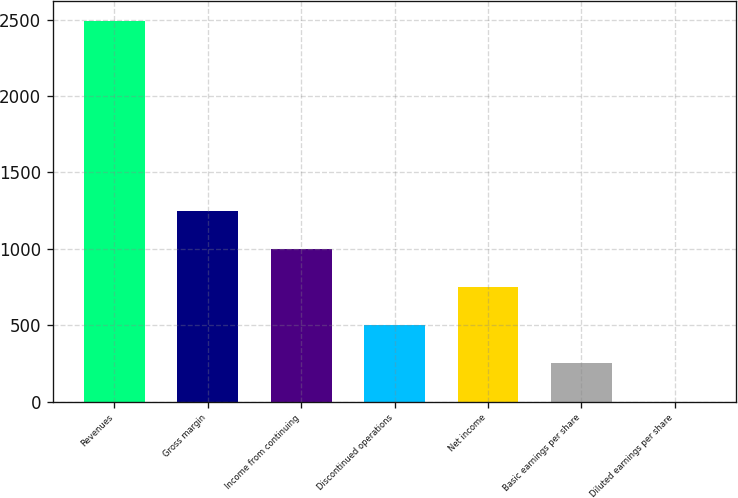<chart> <loc_0><loc_0><loc_500><loc_500><bar_chart><fcel>Revenues<fcel>Gross margin<fcel>Income from continuing<fcel>Discontinued operations<fcel>Net income<fcel>Basic earnings per share<fcel>Diluted earnings per share<nl><fcel>2495<fcel>1247.6<fcel>998.12<fcel>499.16<fcel>748.64<fcel>249.68<fcel>0.2<nl></chart> 